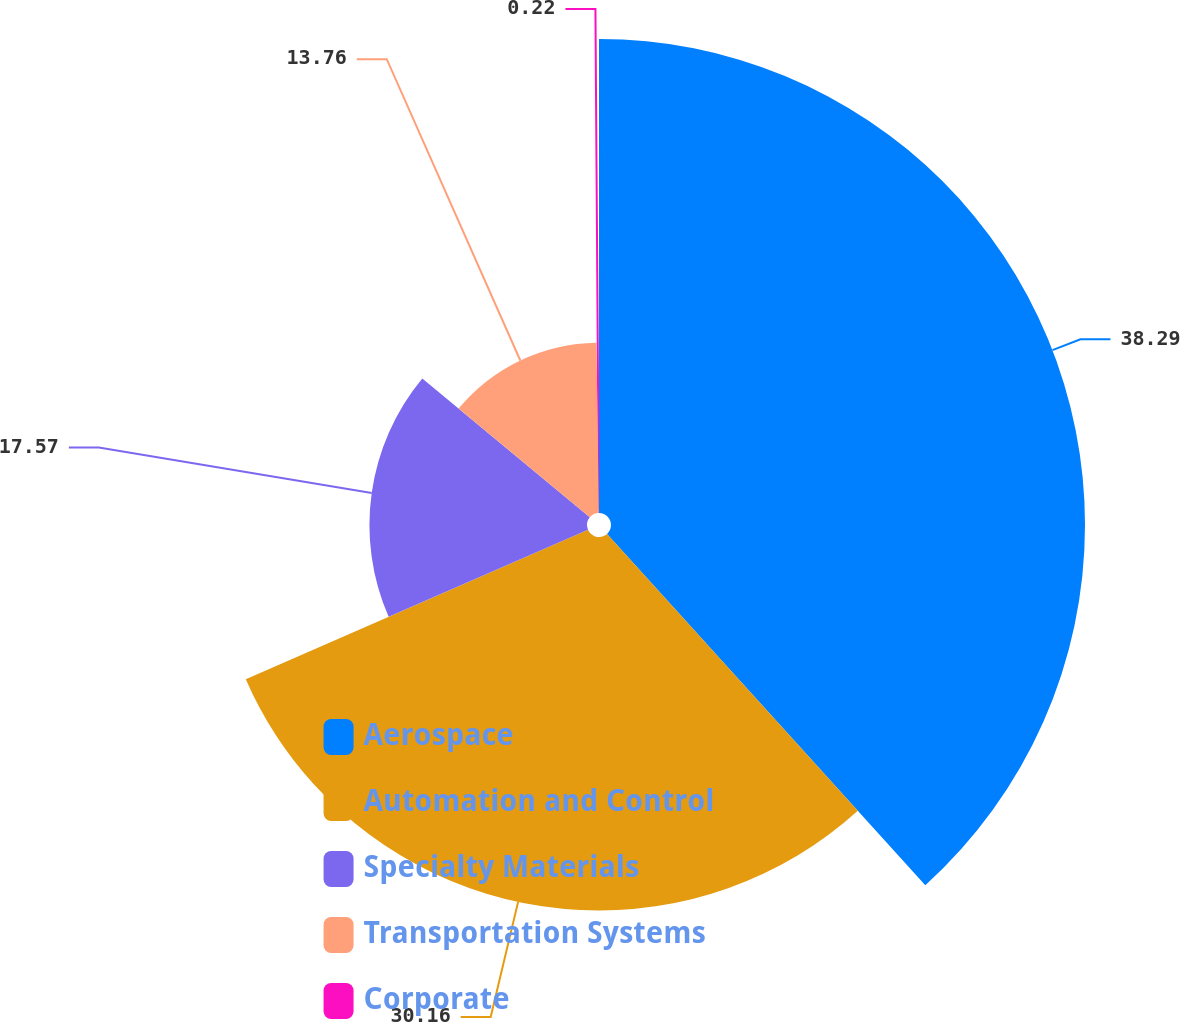Convert chart. <chart><loc_0><loc_0><loc_500><loc_500><pie_chart><fcel>Aerospace<fcel>Automation and Control<fcel>Specialty Materials<fcel>Transportation Systems<fcel>Corporate<nl><fcel>38.28%<fcel>30.16%<fcel>17.57%<fcel>13.76%<fcel>0.22%<nl></chart> 